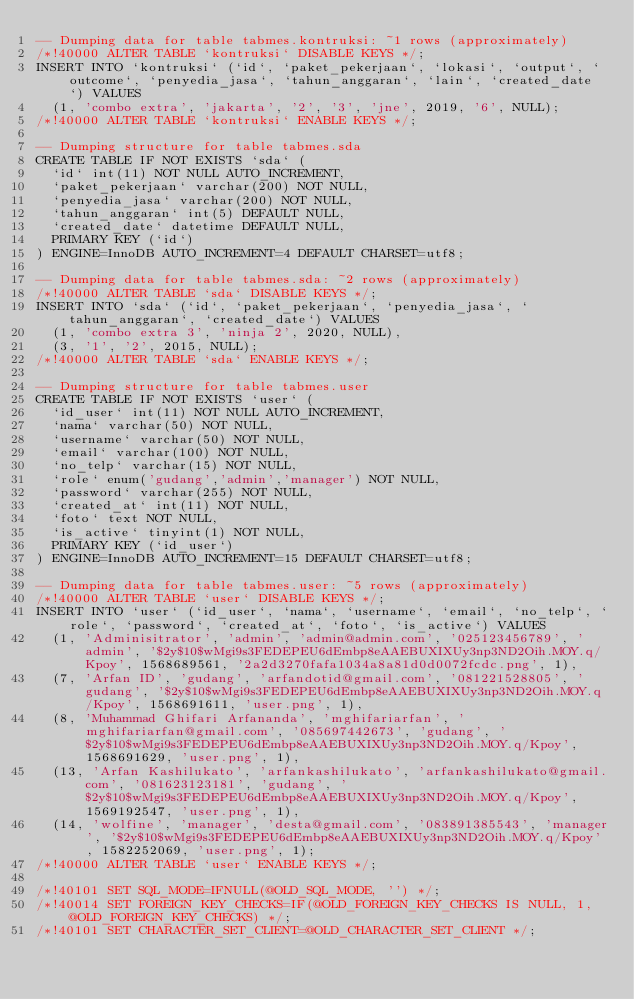<code> <loc_0><loc_0><loc_500><loc_500><_SQL_>-- Dumping data for table tabmes.kontruksi: ~1 rows (approximately)
/*!40000 ALTER TABLE `kontruksi` DISABLE KEYS */;
INSERT INTO `kontruksi` (`id`, `paket_pekerjaan`, `lokasi`, `output`, `outcome`, `penyedia_jasa`, `tahun_anggaran`, `lain`, `created_date`) VALUES
	(1, 'combo extra', 'jakarta', '2', '3', 'jne', 2019, '6', NULL);
/*!40000 ALTER TABLE `kontruksi` ENABLE KEYS */;

-- Dumping structure for table tabmes.sda
CREATE TABLE IF NOT EXISTS `sda` (
  `id` int(11) NOT NULL AUTO_INCREMENT,
  `paket_pekerjaan` varchar(200) NOT NULL,
  `penyedia_jasa` varchar(200) NOT NULL,
  `tahun_anggaran` int(5) DEFAULT NULL,
  `created_date` datetime DEFAULT NULL,
  PRIMARY KEY (`id`)
) ENGINE=InnoDB AUTO_INCREMENT=4 DEFAULT CHARSET=utf8;

-- Dumping data for table tabmes.sda: ~2 rows (approximately)
/*!40000 ALTER TABLE `sda` DISABLE KEYS */;
INSERT INTO `sda` (`id`, `paket_pekerjaan`, `penyedia_jasa`, `tahun_anggaran`, `created_date`) VALUES
	(1, 'combo extra 3', 'ninja 2', 2020, NULL),
	(3, '1', '2', 2015, NULL);
/*!40000 ALTER TABLE `sda` ENABLE KEYS */;

-- Dumping structure for table tabmes.user
CREATE TABLE IF NOT EXISTS `user` (
  `id_user` int(11) NOT NULL AUTO_INCREMENT,
  `nama` varchar(50) NOT NULL,
  `username` varchar(50) NOT NULL,
  `email` varchar(100) NOT NULL,
  `no_telp` varchar(15) NOT NULL,
  `role` enum('gudang','admin','manager') NOT NULL,
  `password` varchar(255) NOT NULL,
  `created_at` int(11) NOT NULL,
  `foto` text NOT NULL,
  `is_active` tinyint(1) NOT NULL,
  PRIMARY KEY (`id_user`)
) ENGINE=InnoDB AUTO_INCREMENT=15 DEFAULT CHARSET=utf8;

-- Dumping data for table tabmes.user: ~5 rows (approximately)
/*!40000 ALTER TABLE `user` DISABLE KEYS */;
INSERT INTO `user` (`id_user`, `nama`, `username`, `email`, `no_telp`, `role`, `password`, `created_at`, `foto`, `is_active`) VALUES
	(1, 'Adminisitrator', 'admin', 'admin@admin.com', '025123456789', 'admin', '$2y$10$wMgi9s3FEDEPEU6dEmbp8eAAEBUXIXUy3np3ND2Oih.MOY.q/Kpoy', 1568689561, '2a2d3270fafa1034a8a81d0d0072fcdc.png', 1),
	(7, 'Arfan ID', 'gudang', 'arfandotid@gmail.com', '081221528805', 'gudang', '$2y$10$wMgi9s3FEDEPEU6dEmbp8eAAEBUXIXUy3np3ND2Oih.MOY.q/Kpoy', 1568691611, 'user.png', 1),
	(8, 'Muhammad Ghifari Arfananda', 'mghifariarfan', 'mghifariarfan@gmail.com', '085697442673', 'gudang', '$2y$10$wMgi9s3FEDEPEU6dEmbp8eAAEBUXIXUy3np3ND2Oih.MOY.q/Kpoy', 1568691629, 'user.png', 1),
	(13, 'Arfan Kashilukato', 'arfankashilukato', 'arfankashilukato@gmail.com', '081623123181', 'gudang', '$2y$10$wMgi9s3FEDEPEU6dEmbp8eAAEBUXIXUy3np3ND2Oih.MOY.q/Kpoy', 1569192547, 'user.png', 1),
	(14, 'wolfine', 'manager', 'desta@gmail.com', '083891385543', 'manager', '$2y$10$wMgi9s3FEDEPEU6dEmbp8eAAEBUXIXUy3np3ND2Oih.MOY.q/Kpoy', 1582252069, 'user.png', 1);
/*!40000 ALTER TABLE `user` ENABLE KEYS */;

/*!40101 SET SQL_MODE=IFNULL(@OLD_SQL_MODE, '') */;
/*!40014 SET FOREIGN_KEY_CHECKS=IF(@OLD_FOREIGN_KEY_CHECKS IS NULL, 1, @OLD_FOREIGN_KEY_CHECKS) */;
/*!40101 SET CHARACTER_SET_CLIENT=@OLD_CHARACTER_SET_CLIENT */;
</code> 